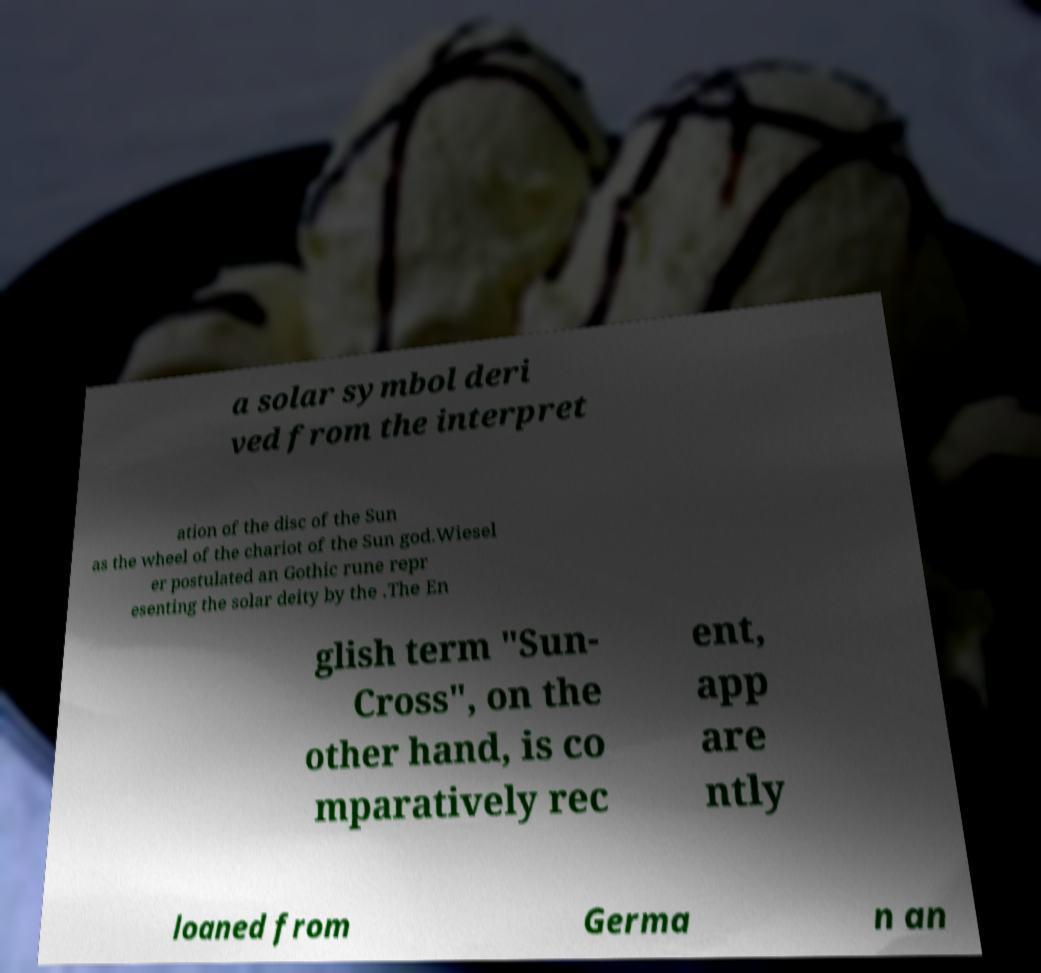Could you assist in decoding the text presented in this image and type it out clearly? a solar symbol deri ved from the interpret ation of the disc of the Sun as the wheel of the chariot of the Sun god.Wiesel er postulated an Gothic rune repr esenting the solar deity by the .The En glish term "Sun- Cross", on the other hand, is co mparatively rec ent, app are ntly loaned from Germa n an 